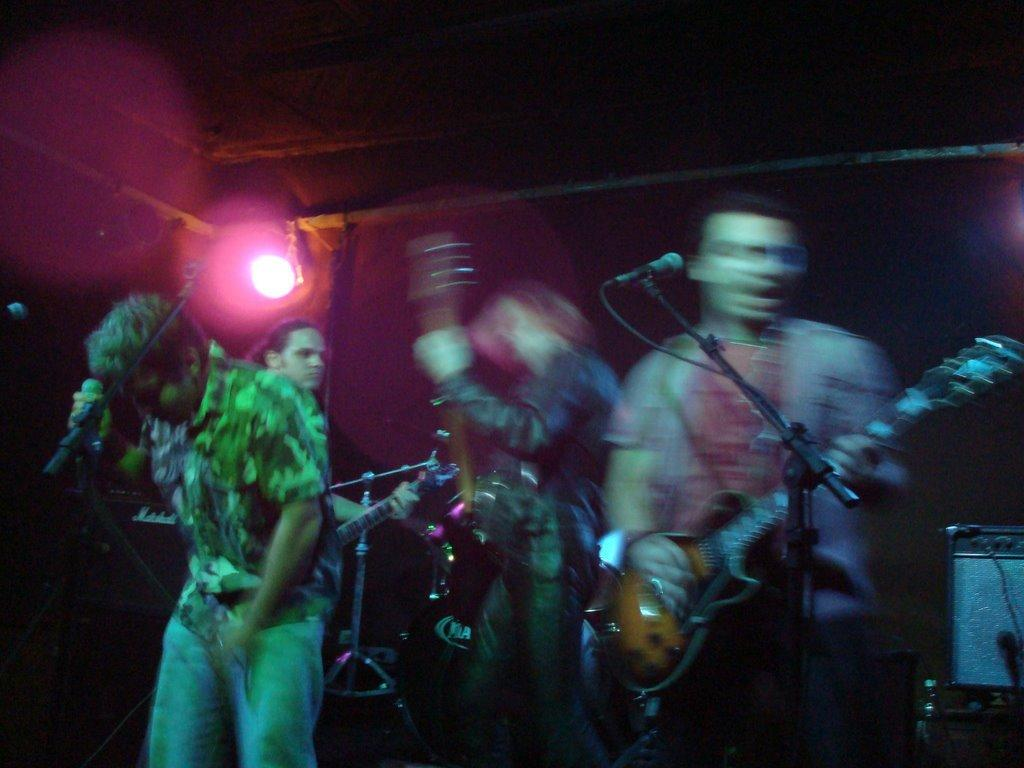How many people are standing in the image? There are four persons standing in the image. What are two of the persons holding? Two of the persons are holding guitars. What is the third person holding? The third person is holding a microphone. Can you describe the background in the image? There is a background with focusing light. What type of yoke can be seen in the image? There is no yoke present in the image. How does the hose connect to the form in the image? There is no hose or form present in the image. 